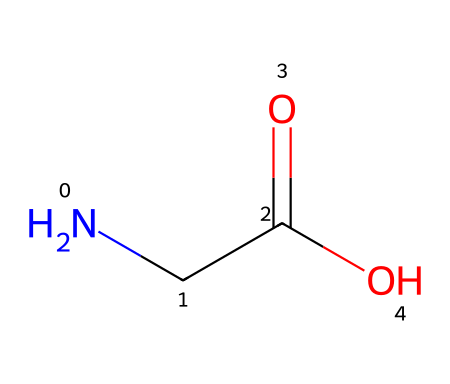What is the name of this chemical? The provided SMILES representation corresponds to glycine, which is the simplest amino acid. This can be identified by recognizing the structure and the elements present (N, C, O) that constitute glycine.
Answer: glycine How many carbon atoms are in glycine? Analyzing the SMILES representation, it shows "NCC(=O)O", where "C" appears twice, indicating there are two carbon atoms in the structure of glycine.
Answer: 2 What functional groups are present in glycine? Examining the SMILES "NCC(=O)O", we see an amine group (NH2) and a carboxylic acid group (COOH). The presence of both groups indicates that glycine is an amino acid, consisting of these functional groups.
Answer: amine and carboxylic acid How many nitrogen atoms does glycine contain? From the SMILES representation "NCC(=O)O", the initial "N" indicates there is one nitrogen atom present in the structure of glycine.
Answer: 1 What type of chemical is glycine categorized as? Glycine is considered a zwitterionic compound because it contains both a positive charge on the amine group and a negative charge on the carboxylate group at physiological pH. This can be deduced from the presence of both functional groups in its structure.
Answer: zwitterion What is the molecular weight of glycine? Calculating the molecular weight involves adding the atomic weights of its constituent atoms from the SMILES representation "NCC(=O)O", which contains 2 carbon (C), 5 hydrogen (H), 1 nitrogen (N), and 2 oxygen (O). This adds up to a molecular weight of approximately 75.07 g/mol.
Answer: 75.07 g/mol 